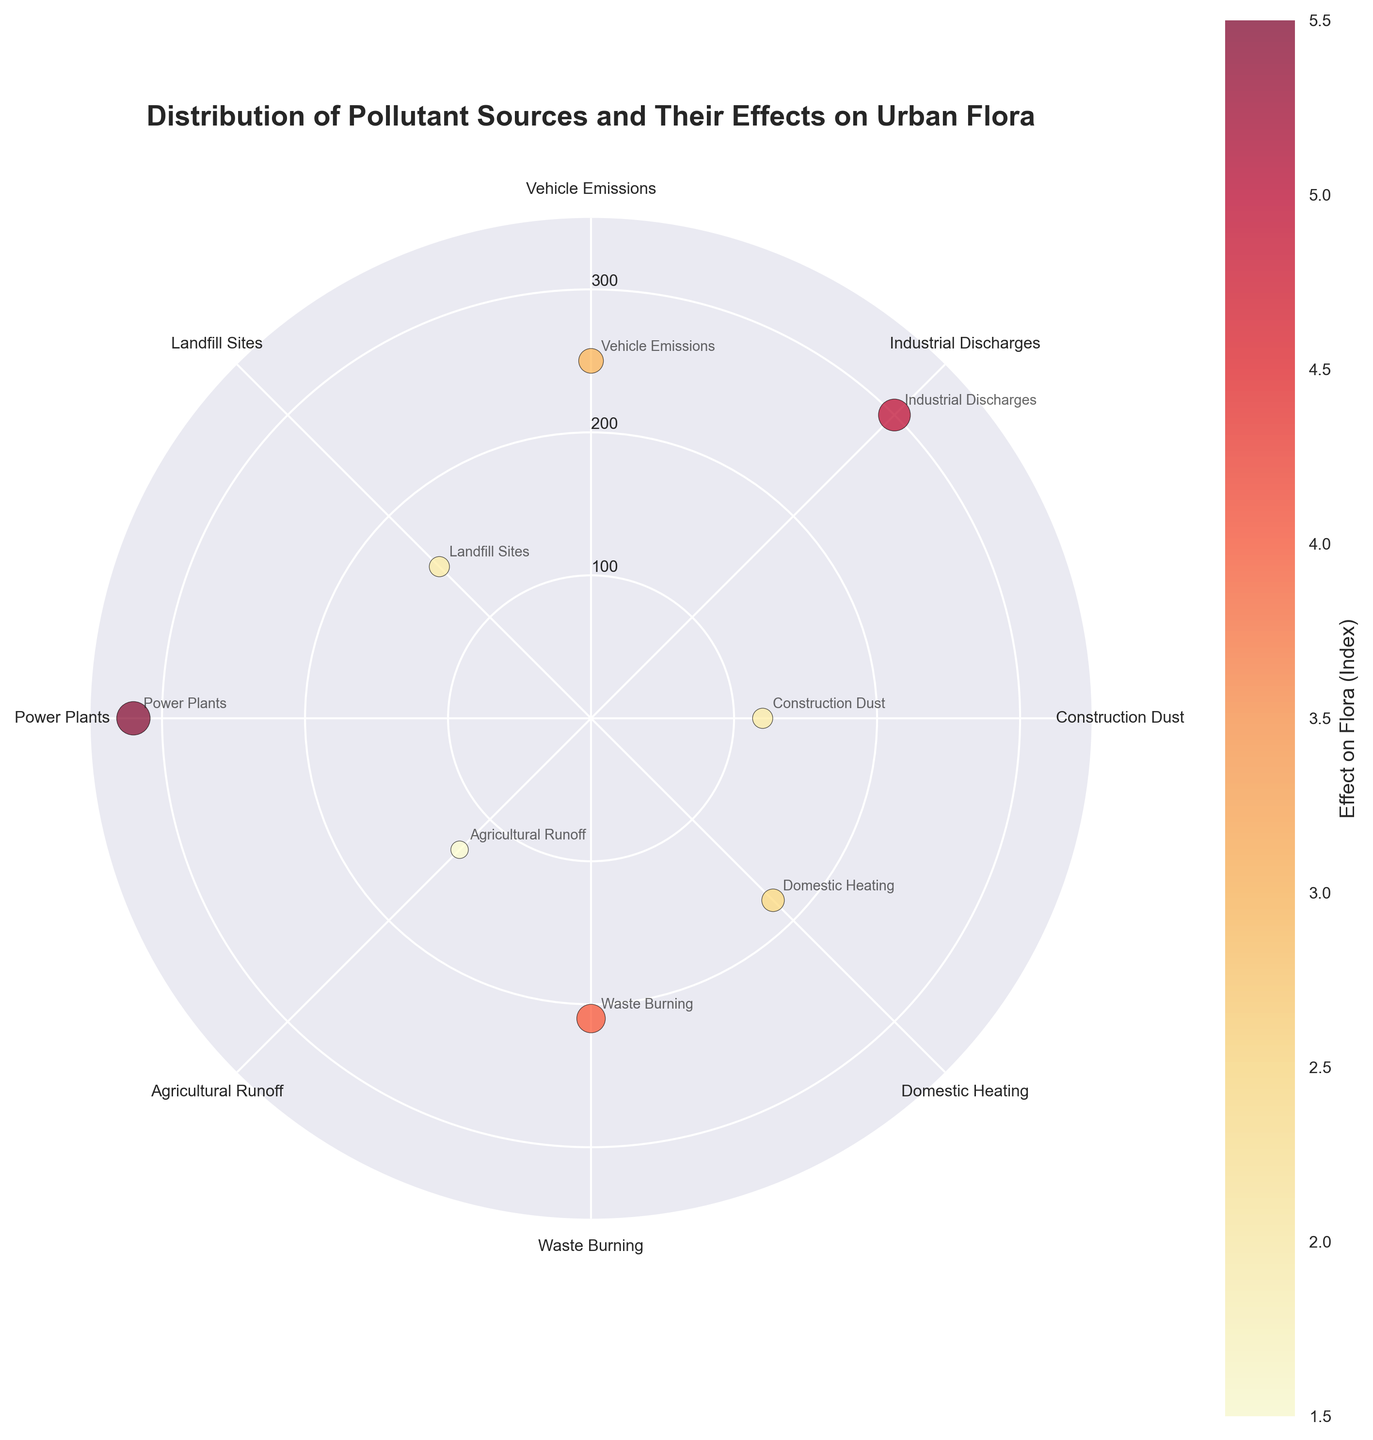What is the title of the figure? The title is displayed at the top of the Polar Scatter Chart and reads "Distribution of Pollutant Sources and Their Effects on Urban Flora".
Answer: Distribution of Pollutant Sources and Their Effects on Urban Flora How many pollutant sources are represented in the figure? The figure includes one scatter point for each pollutant source. By counting the annotations around the scatter points, we can determine that there are 8 pollutant sources.
Answer: 8 What pollutant source has the highest pollution level, and what is its associated effect on flora index? The pollution levels are represented by the radial distance from the center, and the highest radial distance denotes the highest pollution level. The annotation for the outermost point is Power Plants, and its radial distance correlates to a pollution level of 320 ug/m3. The color and size of the dot indicate an effect on flora index of 5.5.
Answer: Power Plants, 5.5 Which pollutant source has the lowest pollution level? What is its effect on flora index? The inner points on the chart represent the lower pollution levels. The closest point to the center is Construction Dust with a pollution level of 120 ug/m3. The effect on flora index for this point can be determined by the dot's color and size, which is 2.
Answer: Construction Dust, 2 Compare the effect on flora index between Industrial Discharges and Domestic Heating. Which has a higher index? The effects on flora index are represented by the dot's color and size. The annotations around the chart identify each source's effect on the flora index. Industrial Discharges has an index of 5, while Domestic Heating has an index of 2.5.
Answer: Industrial Discharges How does the Pollution Level of Waste Burning compare to Landfill Sites? By looking at the radial distances for both scatter points, you can see that Waste Burning is further out than Landfill Sites, indicating that Waste Burning has a higher pollution level of 210 ug/m3 compared to 150 ug/m3 for Landfill Sites.
Answer: Waste Burning is higher What is the average effect on flora index for all the pollutant sources? To find the average, sum all the effects on flora indices: 3 (Vehicle Emissions) + 5 (Industrial Discharges) + 2 (Construction Dust) + 2.5 (Domestic Heating) + 4 (Waste Burning) + 1.5 (Agricultural Runoff) + 5.5 (Power Plants) + 2 (Landfill Sites) = 25.5. Divide by the number of sources (8): 25.5/8.
Answer: 3.19 How does the Pollution Level for Vehicle Emissions compare to Agricultural Runoff? Comparing the radial distances for both points, Vehicle Emissions has a pollution level of 250 ug/m3, while Agricultural Runoff has a pollution level of 130 ug/m3.
Answer: Vehicle Emissions is higher What range does the color bar represent for the effect on flora index? The color bar shows the range from the lowest to the highest effect on flora index. The color bar label and tick marks indicate the index ranges from 1.5 to 5.5.
Answer: 1.5 to 5.5 At which degree angles are the pollutant sources with the highest (5.5) and lowest (1.5) effects on flora located? The pollutant source with the highest effect is Power Plants at 270 degrees, and the source with the lowest effect is Agricultural Runoff at 225 degrees.
Answer: 270 degrees, 225 degrees 